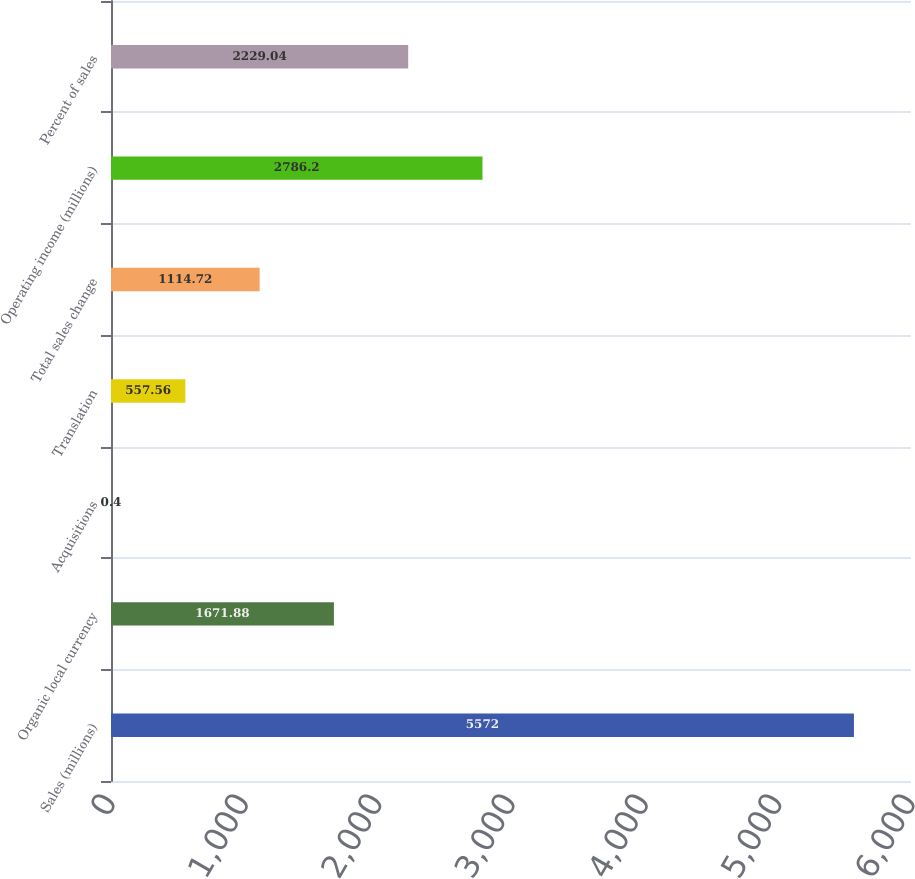<chart> <loc_0><loc_0><loc_500><loc_500><bar_chart><fcel>Sales (millions)<fcel>Organic local currency<fcel>Acquisitions<fcel>Translation<fcel>Total sales change<fcel>Operating income (millions)<fcel>Percent of sales<nl><fcel>5572<fcel>1671.88<fcel>0.4<fcel>557.56<fcel>1114.72<fcel>2786.2<fcel>2229.04<nl></chart> 